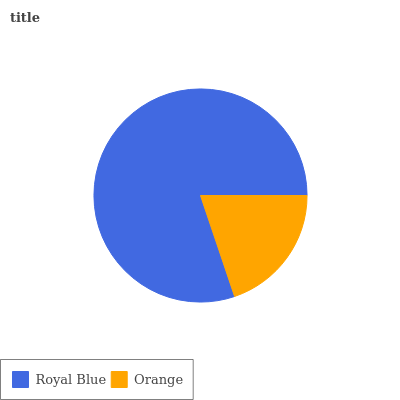Is Orange the minimum?
Answer yes or no. Yes. Is Royal Blue the maximum?
Answer yes or no. Yes. Is Orange the maximum?
Answer yes or no. No. Is Royal Blue greater than Orange?
Answer yes or no. Yes. Is Orange less than Royal Blue?
Answer yes or no. Yes. Is Orange greater than Royal Blue?
Answer yes or no. No. Is Royal Blue less than Orange?
Answer yes or no. No. Is Royal Blue the high median?
Answer yes or no. Yes. Is Orange the low median?
Answer yes or no. Yes. Is Orange the high median?
Answer yes or no. No. Is Royal Blue the low median?
Answer yes or no. No. 